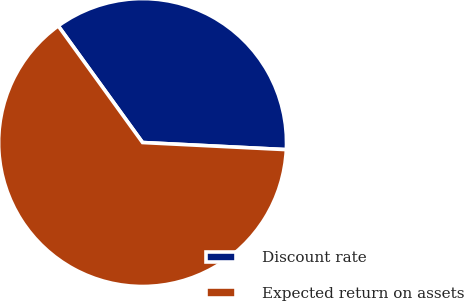Convert chart to OTSL. <chart><loc_0><loc_0><loc_500><loc_500><pie_chart><fcel>Discount rate<fcel>Expected return on assets<nl><fcel>35.75%<fcel>64.25%<nl></chart> 